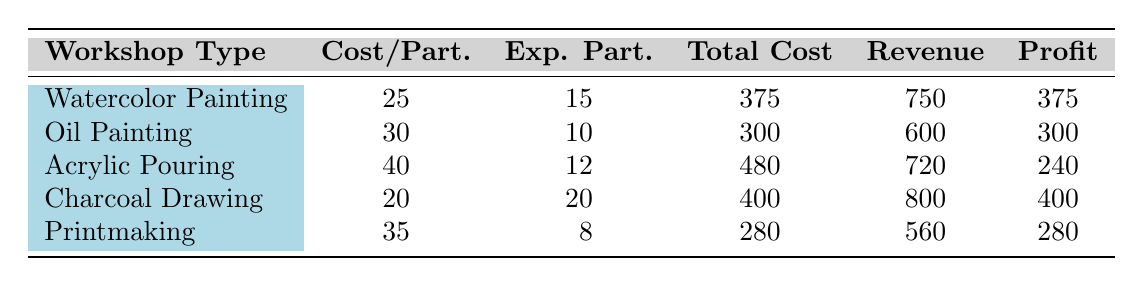What is the total revenue generated from the Charcoal Drawing workshop? The table shows that the revenue for the Charcoal Drawing workshop is specifically listed as 800.
Answer: 800 Which workshop has the highest profit? By comparing the profit row: Watercolor Painting has a profit of 375, Oil Painting has 300, Acrylic Pouring has 240, Charcoal Drawing has 400, and Printmaking has 280. The highest value is 400 from the Charcoal Drawing workshop.
Answer: Charcoal Drawing What is the average cost per participant across all workshops? To find the average cost, we add all cost per participant values: 25 + 30 + 40 + 20 + 35 = 150. There are 5 workshops, so the average is 150/5 = 30.
Answer: 30 Is Oil Painting workshop more profitable than Acrylic Pouring workshop? The profit for Oil Painting is 300 and for Acrylic Pouring is 240. Since 300 is greater than 240, the statement is true.
Answer: Yes What is the total cost of all workshops combined? The total costs are 375 (Watercolor Painting) + 300 (Oil Painting) + 480 (Acrylic Pouring) + 400 (Charcoal Drawing) + 280 (Printmaking) = 1835.
Answer: 1835 How much profit is generated by the Printmaking workshop compared to Charcoal Drawing? Profit for Printmaking is 280 and for Charcoal Drawing is 400. The difference is: 400 - 280 = 120, meaning Charcoal Drawing generates 120 more profit than Printmaking.
Answer: Charcoal Drawing generates 120 more profit Which workshop type has the least expected participants? By looking at the expected participants: Watercolor Painting has 15, Oil Painting has 10, Acrylic Pouring has 12, Charcoal Drawing has 20, and Printmaking has 8. Therefore, Printmaking has the least expected participants at 8.
Answer: Printmaking What is the profit margin of the Watercolor Painting workshop? The profit margin is calculated as profit divided by revenue. Watercolor Painting profit is 375, and revenue is 750. Thus, profit margin = 375 / 750 = 0.5 or 50%.
Answer: 50% 